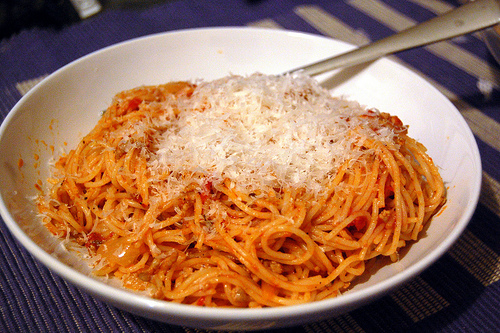<image>
Is the fork in the pasta? Yes. The fork is contained within or inside the pasta, showing a containment relationship. 